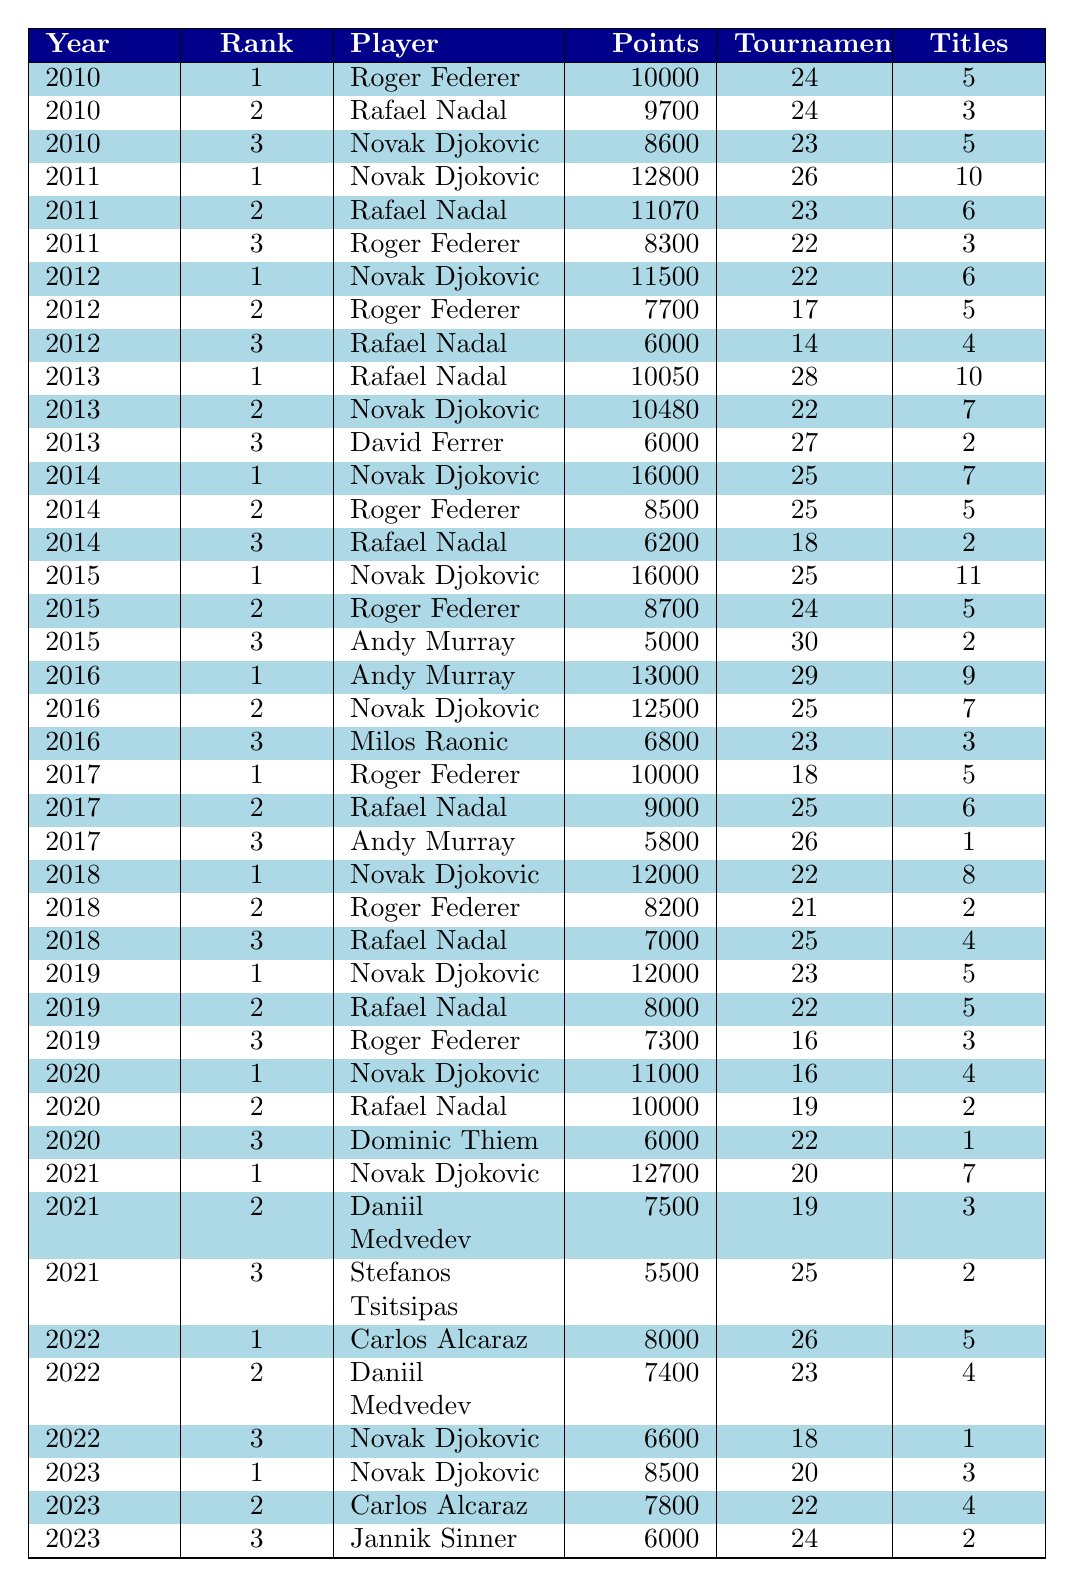What was the highest points total achieved by a player in 2011? In 2011, the player with the highest points total was Novak Djokovic, who achieved 12,800 points.
Answer: 12800 Who ranked second in 2014? In 2014, Roger Federer ranked second with 8,500 points.
Answer: Roger Federer What is the total number of tournaments played by Novak Djokovic from 2011 to 2015? Adding the tournaments played by Novak Djokovic in 2011 (26), 2012 (22), 2014 (25), and 2015 (25) gives a total of 98 tournaments (26 + 22 + 25 + 25).
Answer: 98 Did Rafael Nadal ever have a ranking of 1 before 2014? Yes, Rafael Nadal was ranked 1 in 2013.
Answer: Yes Who had the most titles in 2015, and how many did they have? In 2015, Novak Djokovic had the most titles with 11.
Answer: Novak Djokovic, 11 titles What is the average number of tournaments played by the top three players in 2022? The total number of tournaments played by the top three players in 2022 is 26 (Carlos Alcaraz) + 23 (Daniil Medvedev) + 18 (Novak Djokovic) = 67. Therefore, the average is 67 / 3 = 22.33.
Answer: 22.33 Which player had the lowest points in 2023 and what were those points? In 2023, Jannik Sinner had the lowest points with 6,000.
Answer: 6000 Over the years from 2010 to 2023, how many times was Novak Djokovic ranked 1? Novak Djokovic was ranked 1 in 2011, 2012, 2014, 2015, 2016, 2018, 2019, 2020, 2021, and 2023, totaling 10 times.
Answer: 10 times Which year saw the highest sum of points for the top three players, and what was that sum? In 2015, the top three players had a total of 16,000 (Novak Djokovic) + 8,700 (Roger Federer) + 5,000 (Andy Murray) = 29,700 points, the highest sum.
Answer: 29700 Was there ever a year when Roger Federer had more titles than Rafael Nadal? Yes, in 2012, Roger Federer had 5 titles while Rafael Nadal had 4.
Answer: Yes 